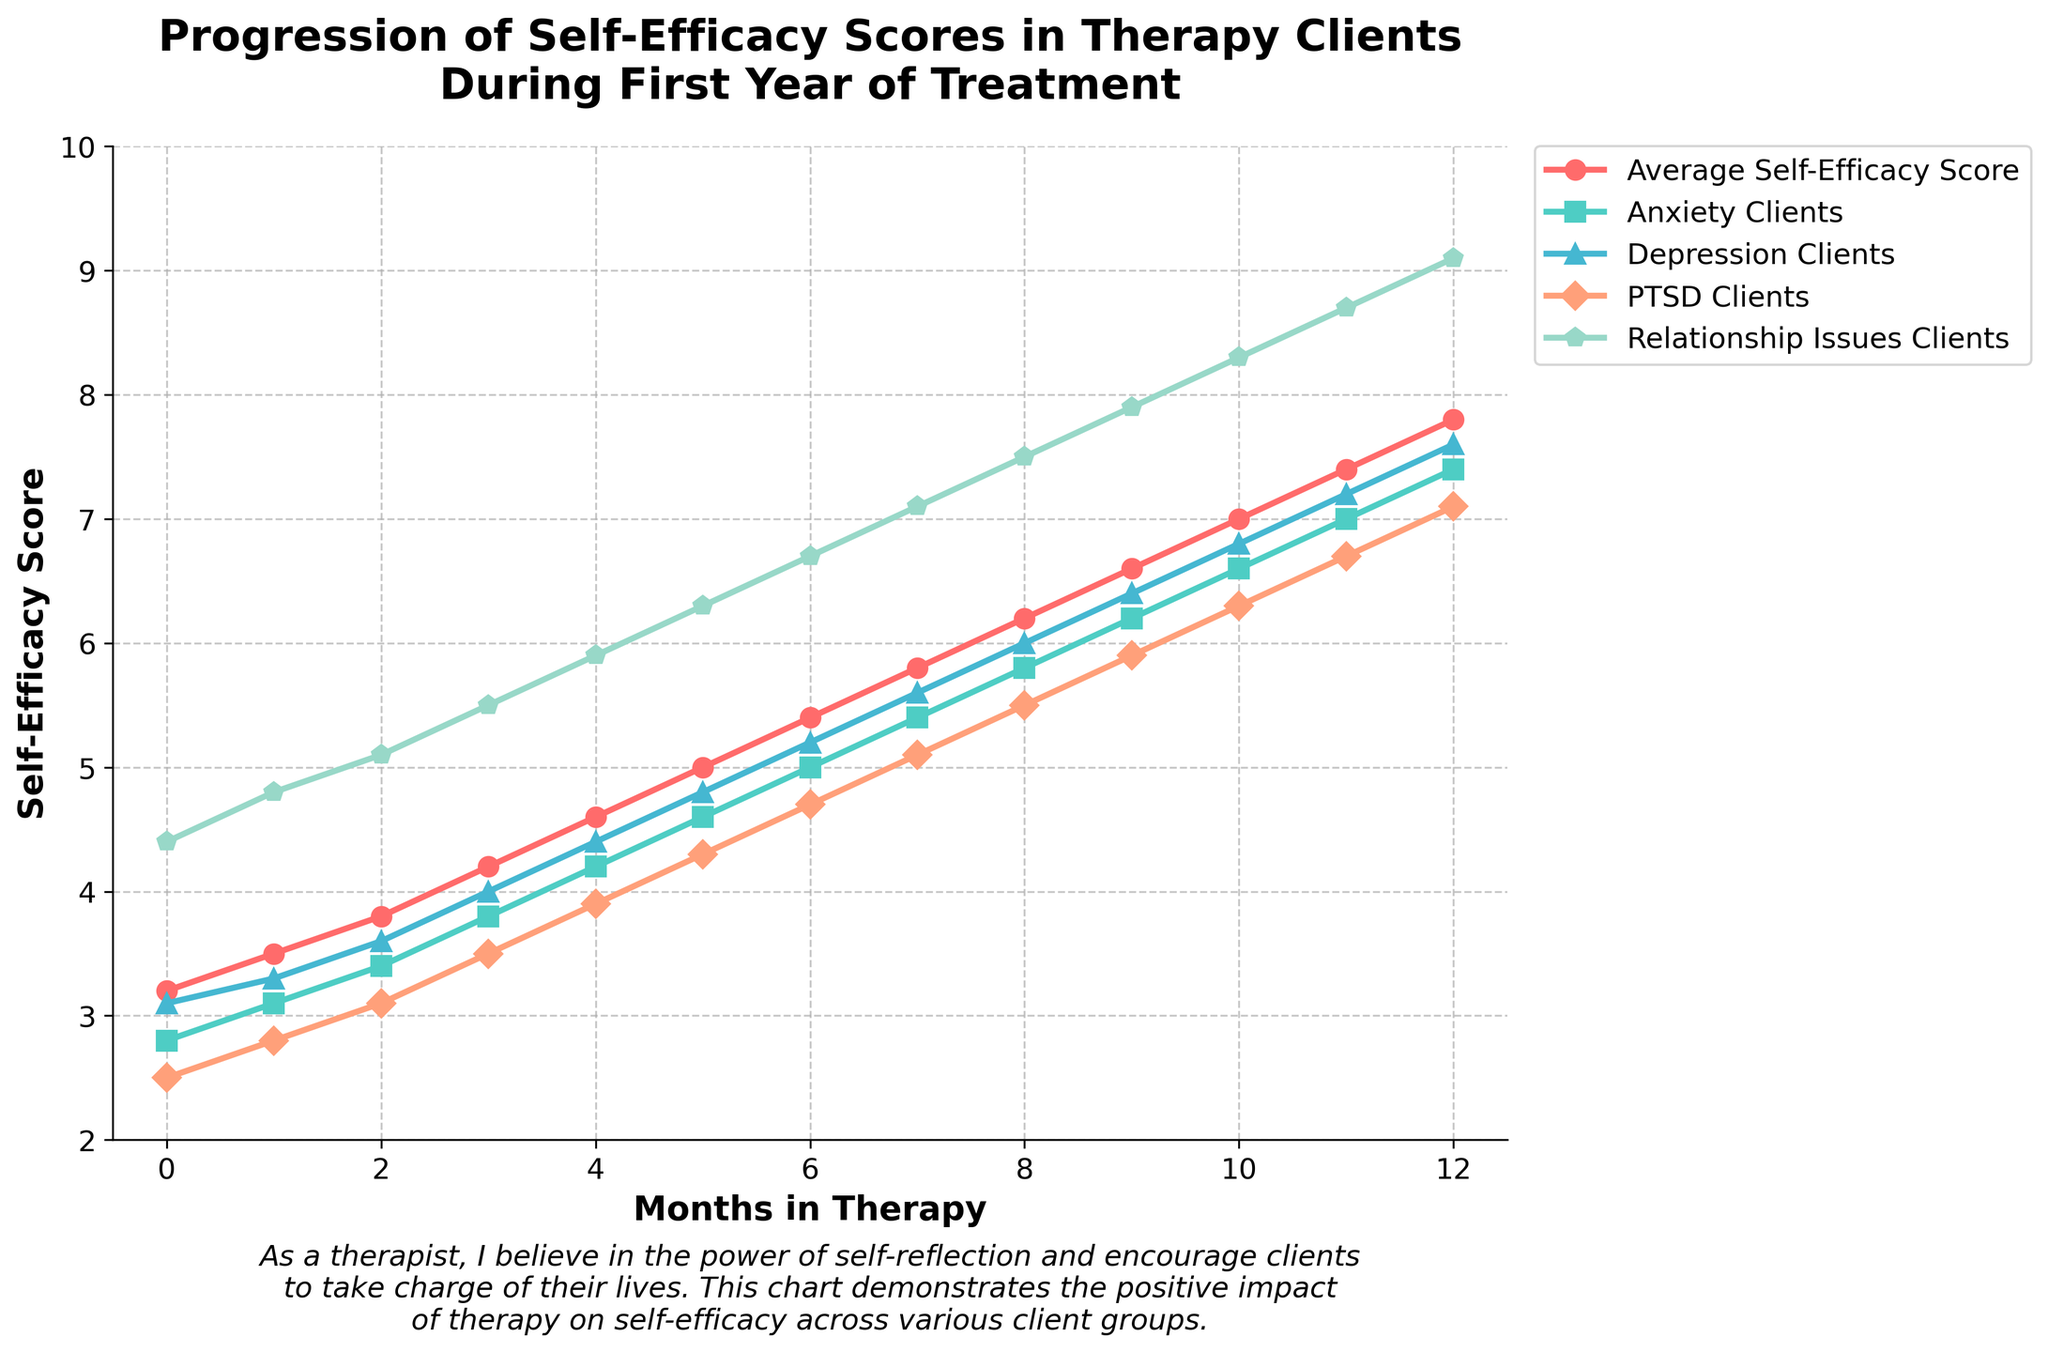Which client group experienced the highest increase in self-efficacy score during the first year of treatment? To determine the group with the highest increase, compare the difference between the 12th-month score and the initial score for each group. For Anxiety Clients: 7.4 - 2.8 = 4.6, Depression Clients: 7.6 - 3.1 = 4.5, PTSD Clients: 7.1 - 2.5 = 4.6, Relationship Issues Clients: 9.1 - 4.4 = 4.7.
Answer: Relationship Issues Clients At which month did the average self-efficacy score exceed 6.0? Look at the 'Average Self-Efficacy Score' data and find the month where the score first goes above 6.0. The data shows it first exceeds 6.0 at the 8th month with a score of 6.2.
Answer: Month 8 How does the self-efficacy score progression for PTSD Clients compare between months 3 and 9? Subtract the score at month 3 from the score at month 9 for PTSD Clients. Month 3: 3.5, Month 9: 5.9, Difference: 5.9 - 3.5 = 2.4.
Answer: Increase of 2.4 Among the client groups, which had a self-efficacy score exactly at 7.0? Find the data point with a score of 7.0. The scores for Anxiety Clients, Depression Clients, PTSD Clients, and Relationship Issues Clients on month 11, show that Anxiety Clients had a score of 7.0.
Answer: Anxiety Clients How many groups had self-efficacy scores higher than 5.0 at month 6? Compare the self-efficacy scores of all groups at month 6. Scores: Anxiety Clients: 5.0, Depression Clients: 5.2, PTSD Clients: 4.7, Relationship Issues Clients: 6.7. Groups with scores higher than 5.0 are Depression Clients and Relationship Issues Clients.
Answer: 2 What is the median self-efficacy score for Depression Clients during months 0 to 6? List the Depression Clients’ scores from months 0-6: 3.1, 3.3, 3.6, 4.0, 4.4, 4.8, 5.2. The median is the middle value, which in this case is the 4th score (4.0) because there are seven values.
Answer: 4.0 What is the difference in self-efficacy scores between Anxiety and Relationship Issues Clients at month 5? Subtract the score of Anxiety Clients from the score of Relationship Issues Clients at month 5. Anxiety: 4.6, Relationship Issues: 6.3. Difference: 6.3 - 4.6 = 1.7.
Answer: 1.7 Comparing month 0 and month 12, which group showed the least improvement in self-efficacy scores? Calculate the difference between the scores at month 0 and month 12 for each group. Anxiety Clients: 7.4 - 2.8 = 4.6, Depression Clients: 7.6 - 3.1 = 4.5, PTSD Clients: 7.1 - 2.5 = 4.6, Relationship Issues Clients: 9.1 - 4.4 = 4.7. The least improvement is for Depression Clients with 4.5.
Answer: Depression Clients What visual changes can be noticed in the self-efficacy scores of Relationship Issues Clients? Look at the plot for Relationship Issues Clients (marked in one color) and observe the pattern. The scores continuously and steadily increase, with no dips, from month 0 (4.4) to month 12 (9.1).
Answer: Continuous steep rise Which group had the highest self-efficacy score at month 4? Look at the scores for all groups at month 4. Anxiety Clients: 4.2, Depression Clients: 4.4, PTSD Clients: 3.9, Relationship Issues Clients: 5.9. Relationship Issues Clients has the highest score.
Answer: Relationship Issues Clients 